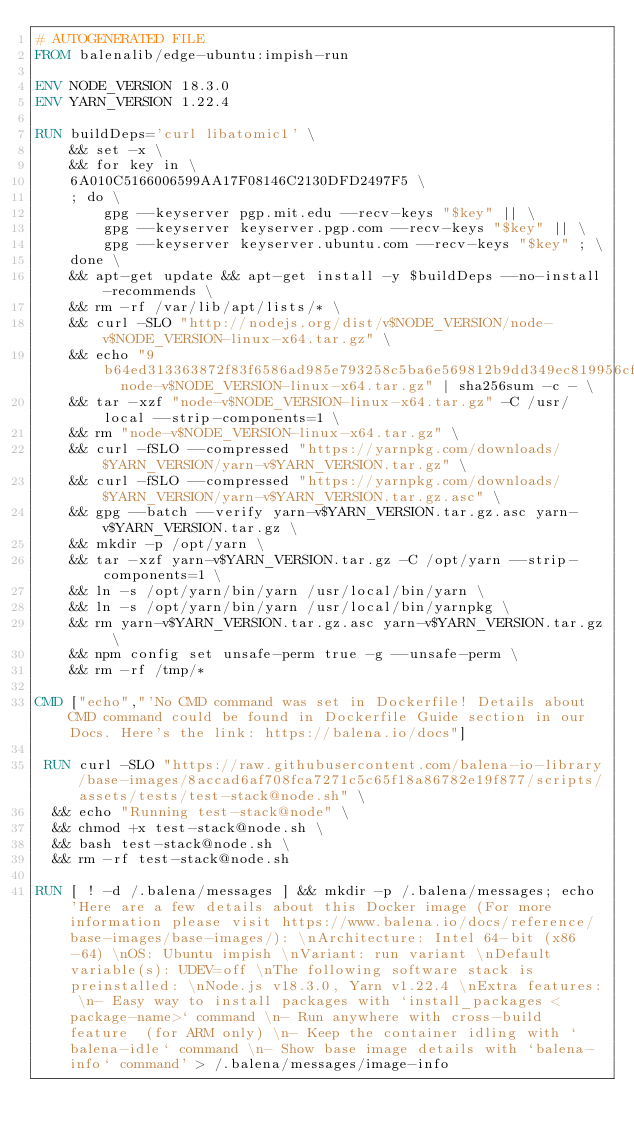Convert code to text. <code><loc_0><loc_0><loc_500><loc_500><_Dockerfile_># AUTOGENERATED FILE
FROM balenalib/edge-ubuntu:impish-run

ENV NODE_VERSION 18.3.0
ENV YARN_VERSION 1.22.4

RUN buildDeps='curl libatomic1' \
	&& set -x \
	&& for key in \
	6A010C5166006599AA17F08146C2130DFD2497F5 \
	; do \
		gpg --keyserver pgp.mit.edu --recv-keys "$key" || \
		gpg --keyserver keyserver.pgp.com --recv-keys "$key" || \
		gpg --keyserver keyserver.ubuntu.com --recv-keys "$key" ; \
	done \
	&& apt-get update && apt-get install -y $buildDeps --no-install-recommends \
	&& rm -rf /var/lib/apt/lists/* \
	&& curl -SLO "http://nodejs.org/dist/v$NODE_VERSION/node-v$NODE_VERSION-linux-x64.tar.gz" \
	&& echo "9b64ed313363872f83f6586ad985e793258c5ba6e569812b9dd349ec819956cf  node-v$NODE_VERSION-linux-x64.tar.gz" | sha256sum -c - \
	&& tar -xzf "node-v$NODE_VERSION-linux-x64.tar.gz" -C /usr/local --strip-components=1 \
	&& rm "node-v$NODE_VERSION-linux-x64.tar.gz" \
	&& curl -fSLO --compressed "https://yarnpkg.com/downloads/$YARN_VERSION/yarn-v$YARN_VERSION.tar.gz" \
	&& curl -fSLO --compressed "https://yarnpkg.com/downloads/$YARN_VERSION/yarn-v$YARN_VERSION.tar.gz.asc" \
	&& gpg --batch --verify yarn-v$YARN_VERSION.tar.gz.asc yarn-v$YARN_VERSION.tar.gz \
	&& mkdir -p /opt/yarn \
	&& tar -xzf yarn-v$YARN_VERSION.tar.gz -C /opt/yarn --strip-components=1 \
	&& ln -s /opt/yarn/bin/yarn /usr/local/bin/yarn \
	&& ln -s /opt/yarn/bin/yarn /usr/local/bin/yarnpkg \
	&& rm yarn-v$YARN_VERSION.tar.gz.asc yarn-v$YARN_VERSION.tar.gz \
	&& npm config set unsafe-perm true -g --unsafe-perm \
	&& rm -rf /tmp/*

CMD ["echo","'No CMD command was set in Dockerfile! Details about CMD command could be found in Dockerfile Guide section in our Docs. Here's the link: https://balena.io/docs"]

 RUN curl -SLO "https://raw.githubusercontent.com/balena-io-library/base-images/8accad6af708fca7271c5c65f18a86782e19f877/scripts/assets/tests/test-stack@node.sh" \
  && echo "Running test-stack@node" \
  && chmod +x test-stack@node.sh \
  && bash test-stack@node.sh \
  && rm -rf test-stack@node.sh 

RUN [ ! -d /.balena/messages ] && mkdir -p /.balena/messages; echo 'Here are a few details about this Docker image (For more information please visit https://www.balena.io/docs/reference/base-images/base-images/): \nArchitecture: Intel 64-bit (x86-64) \nOS: Ubuntu impish \nVariant: run variant \nDefault variable(s): UDEV=off \nThe following software stack is preinstalled: \nNode.js v18.3.0, Yarn v1.22.4 \nExtra features: \n- Easy way to install packages with `install_packages <package-name>` command \n- Run anywhere with cross-build feature  (for ARM only) \n- Keep the container idling with `balena-idle` command \n- Show base image details with `balena-info` command' > /.balena/messages/image-info</code> 